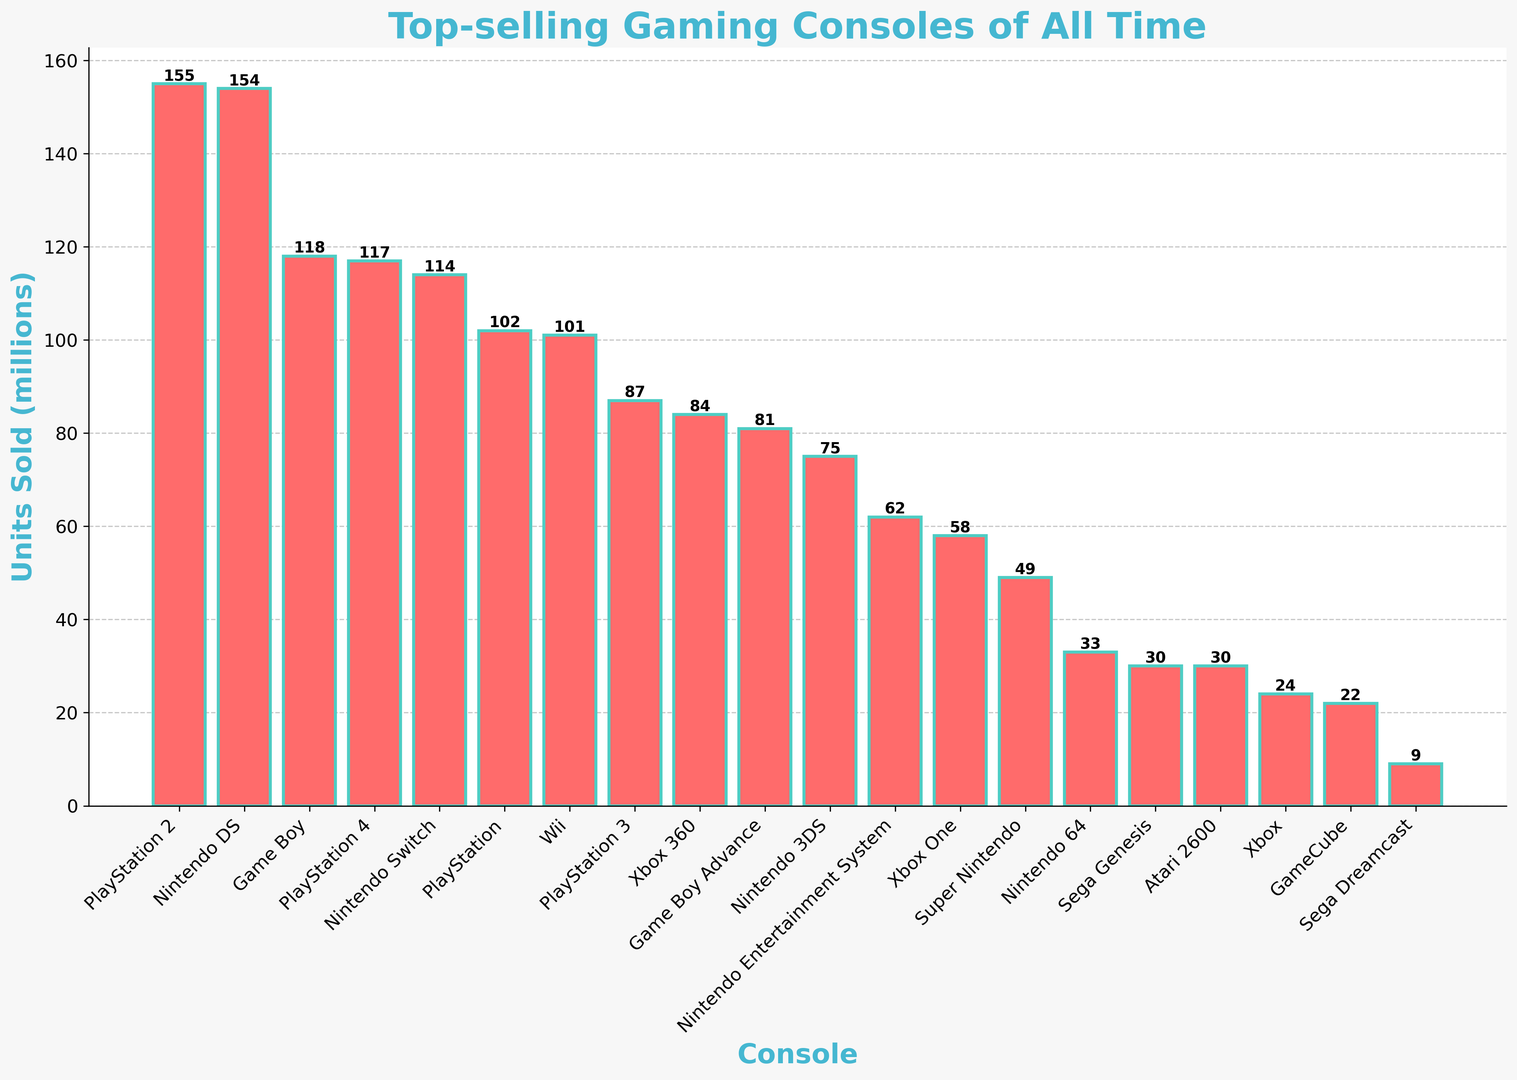What console sold the most units? The console with the highest bar represents the one with the most units sold. According to the chart, the PlayStation 2 sold the most units.
Answer: PlayStation 2 Which console sold more units, Nintendo DS or Xbox 360? Looking at the height of the bars, the Nintendo DS bar is significantly taller than the Xbox 360 bar. The Nintendo DS sold 154 million units while the Xbox 360 sold 84 million units.
Answer: Nintendo DS How many more units did the PlayStation 4 sell compared to the Nintendo Entertainment System (NES)? Find the units sold for the PlayStation 4 (117 million) and the NES (62 million). Subtract the units sold by NES from the PlayStation 4: 117 - 62 = 55 million.
Answer: 55 million What is the total number of units sold for the top 3 consoles? The top 3 consoles are PlayStation 2, Nintendo DS, and Game Boy. Add their units sold: 155 + 154 + 118 = 427 million units.
Answer: 427 million Which console has the smallest bar in the chart? The smallest bar on the chart corresponds to the console with the fewest units sold. The Sega Dreamcast has the smallest bar indicating it sold the least units, which is 9 million.
Answer: Sega Dreamcast How many consoles sold more than 100 million units? Count the number of bars that are taller than the 100 million units mark. These consoles are PlayStation 2, Nintendo DS, Game Boy, PlayStation 4, and Nintendo Switch. So there are 5 consoles.
Answer: 5 consoles What is the average number of units sold among all the listed consoles? Sum up all the units sold and divide by the number of consoles. (155 + 154 + 118 + 117 + 114 + 102 + 101 + 87 + 84 + 81 + 75 + 62 + 58 + 33 + 30 + 30 + 49 + 24 + 22 + 9) / 20 = 75.4 million units.
Answer: 75.4 million units Which PlayStation model sold the least units and how many? Identify the PlayStation models from the chart and compare their units sold. PlayStation 3 sold the least units among PS models with 87 million units sold.
Answer: PlayStation 3, 87 million units What's the difference in units sold between the Nintendo Switch and PlayStation 3? Find the units sold for Nintendo Switch (114 million) and PlayStation 3 (87 million). Subtract the units sold by PlayStation 3 from the Nintendo Switch: 114 - 87 = 27 million.
Answer: 27 million Order the Xbox consoles by units sold from highest to lowest. Identify the Xbox consoles and their units sold: Xbox 360 (84 million), Xbox One (58 million), and Xbox (24 million). The order from highest to lowest is Xbox 360, Xbox One, Xbox.
Answer: Xbox 360, Xbox One, Xbox 